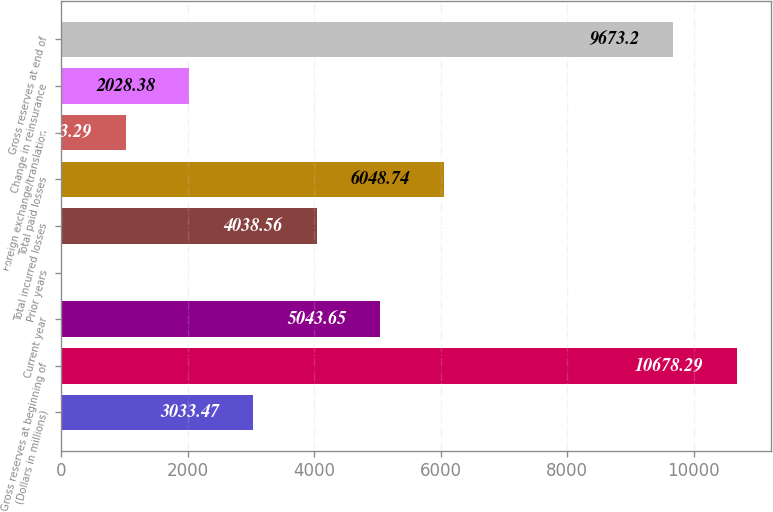Convert chart. <chart><loc_0><loc_0><loc_500><loc_500><bar_chart><fcel>(Dollars in millions)<fcel>Gross reserves at beginning of<fcel>Current year<fcel>Prior years<fcel>Total incurred losses<fcel>Total paid losses<fcel>Foreign exchange/translation<fcel>Change in reinsurance<fcel>Gross reserves at end of<nl><fcel>3033.47<fcel>10678.3<fcel>5043.65<fcel>18.2<fcel>4038.56<fcel>6048.74<fcel>1023.29<fcel>2028.38<fcel>9673.2<nl></chart> 